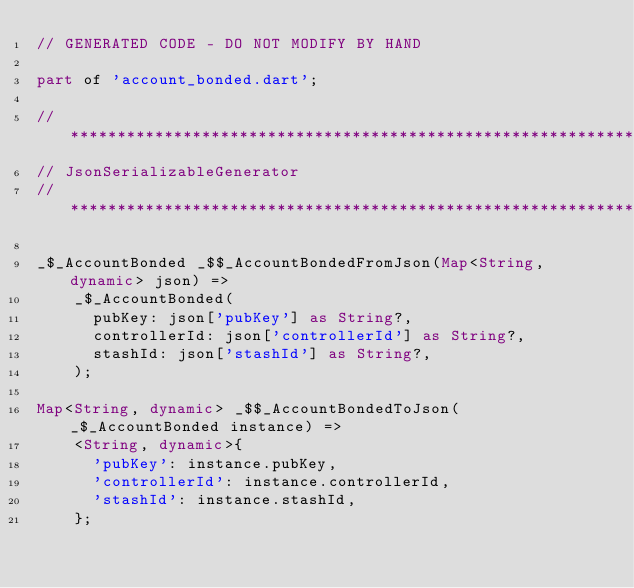Convert code to text. <code><loc_0><loc_0><loc_500><loc_500><_Dart_>// GENERATED CODE - DO NOT MODIFY BY HAND

part of 'account_bonded.dart';

// **************************************************************************
// JsonSerializableGenerator
// **************************************************************************

_$_AccountBonded _$$_AccountBondedFromJson(Map<String, dynamic> json) =>
    _$_AccountBonded(
      pubKey: json['pubKey'] as String?,
      controllerId: json['controllerId'] as String?,
      stashId: json['stashId'] as String?,
    );

Map<String, dynamic> _$$_AccountBondedToJson(_$_AccountBonded instance) =>
    <String, dynamic>{
      'pubKey': instance.pubKey,
      'controllerId': instance.controllerId,
      'stashId': instance.stashId,
    };
</code> 